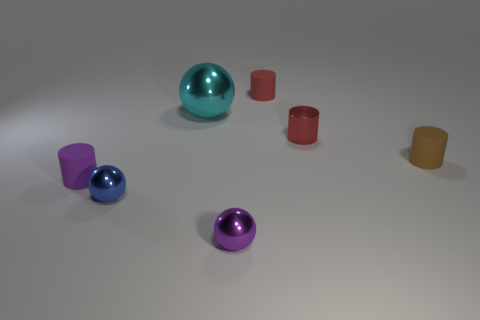There is a small metal object that is left of the small purple metallic thing; what shape is it? sphere 